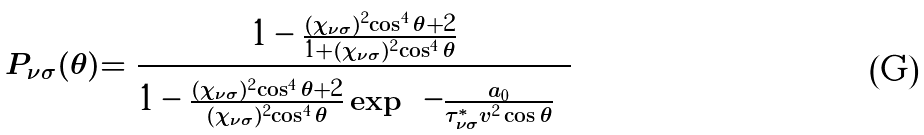Convert formula to latex. <formula><loc_0><loc_0><loc_500><loc_500>P _ { \nu \sigma } ( \theta ) = \frac { 1 - \frac { ( \chi _ { \nu \sigma } ) ^ { 2 } \cos ^ { 4 } \theta + 2 } { 1 + ( \chi _ { \nu \sigma } ) ^ { 2 } \cos ^ { 4 } \theta } } { 1 - \frac { ( \chi _ { \nu \sigma } ) ^ { 2 } \cos ^ { 4 } \theta + 2 } { ( \chi _ { \nu \sigma } ) ^ { 2 } \cos ^ { 4 } \theta } \exp \left ( - \frac { a _ { 0 } } { \tau ^ { * } _ { \nu \sigma } v ^ { 2 } \cos \theta } \right ) }</formula> 